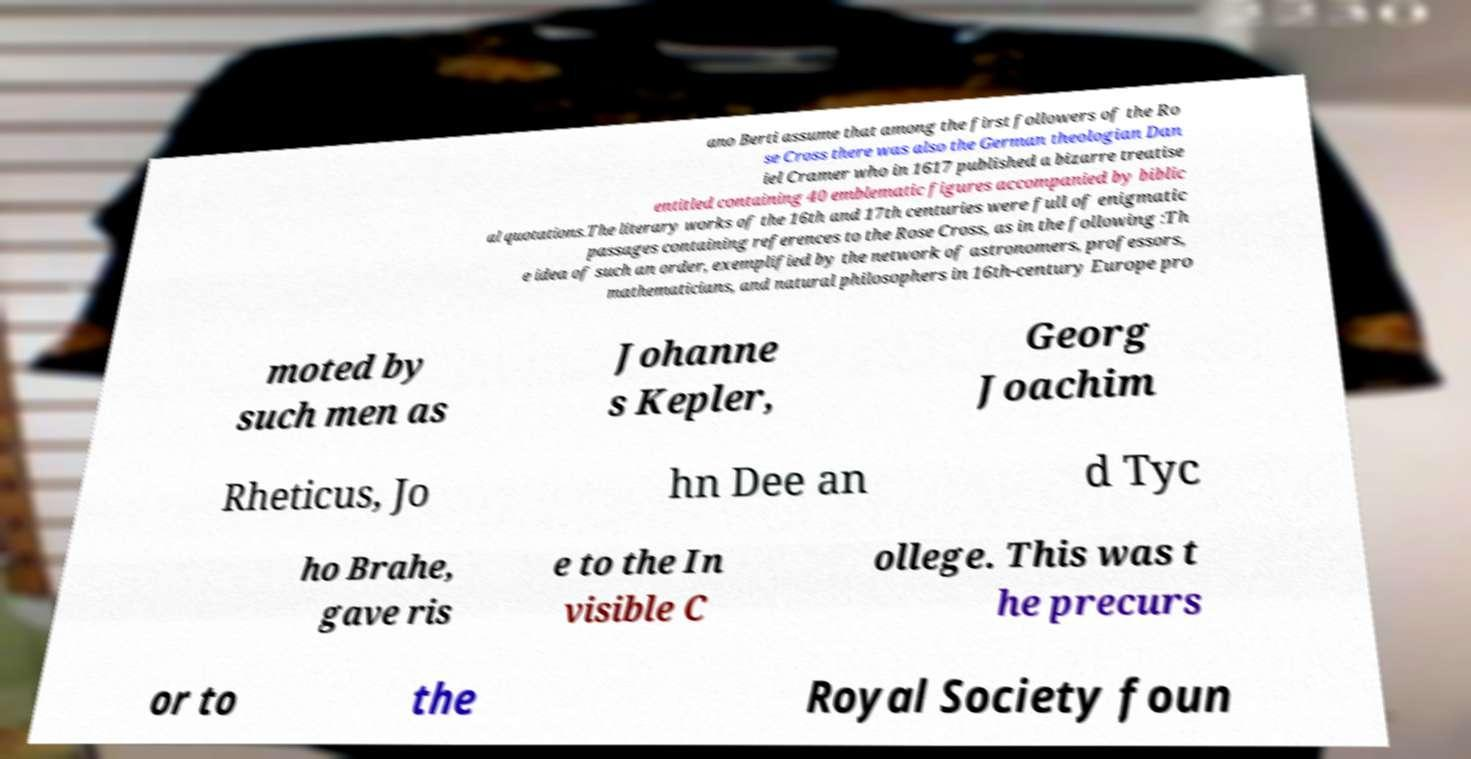Could you assist in decoding the text presented in this image and type it out clearly? ano Berti assume that among the first followers of the Ro se Cross there was also the German theologian Dan iel Cramer who in 1617 published a bizarre treatise entitled containing 40 emblematic figures accompanied by biblic al quotations.The literary works of the 16th and 17th centuries were full of enigmatic passages containing references to the Rose Cross, as in the following :Th e idea of such an order, exemplified by the network of astronomers, professors, mathematicians, and natural philosophers in 16th-century Europe pro moted by such men as Johanne s Kepler, Georg Joachim Rheticus, Jo hn Dee an d Tyc ho Brahe, gave ris e to the In visible C ollege. This was t he precurs or to the Royal Society foun 